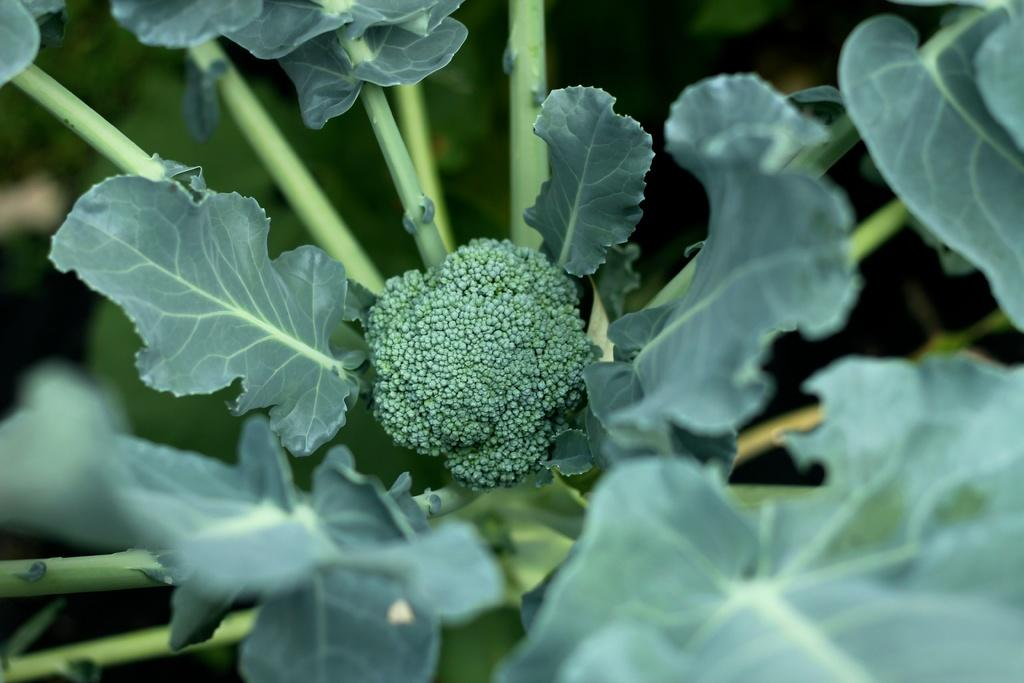What type of flower is present in the image? There is a green color flower in the image. Where is the flower located? The flower is on a plant. What type of dinosaurs can be seen interacting with the flower in the image? There are no dinosaurs present in the image; it features a green color flower on a plant. How does the heat affect the growth of the flower in the image? There is no information about heat in the image, so it cannot be determined how it affects the flower's growth. 